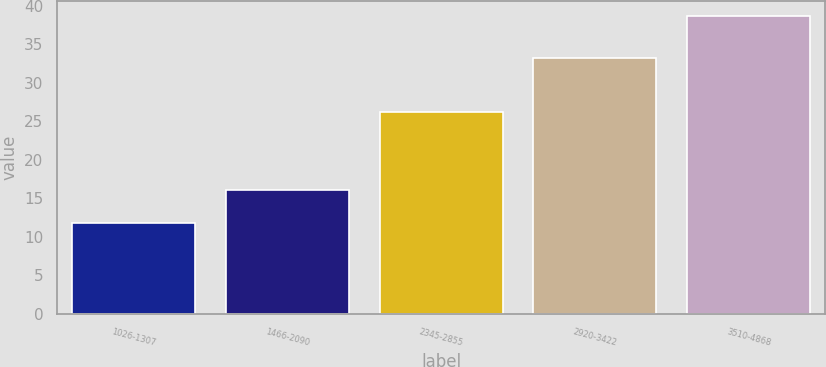<chart> <loc_0><loc_0><loc_500><loc_500><bar_chart><fcel>1026-1307<fcel>1466-2090<fcel>2345-2855<fcel>2920-3422<fcel>3510-4868<nl><fcel>11.85<fcel>16.12<fcel>26.19<fcel>33.25<fcel>38.64<nl></chart> 